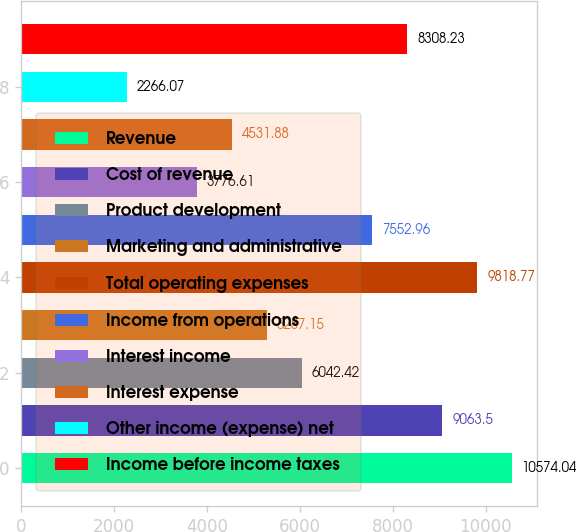Convert chart. <chart><loc_0><loc_0><loc_500><loc_500><bar_chart><fcel>Revenue<fcel>Cost of revenue<fcel>Product development<fcel>Marketing and administrative<fcel>Total operating expenses<fcel>Income from operations<fcel>Interest income<fcel>Interest expense<fcel>Other income (expense) net<fcel>Income before income taxes<nl><fcel>10574<fcel>9063.5<fcel>6042.42<fcel>5287.15<fcel>9818.77<fcel>7552.96<fcel>3776.61<fcel>4531.88<fcel>2266.07<fcel>8308.23<nl></chart> 